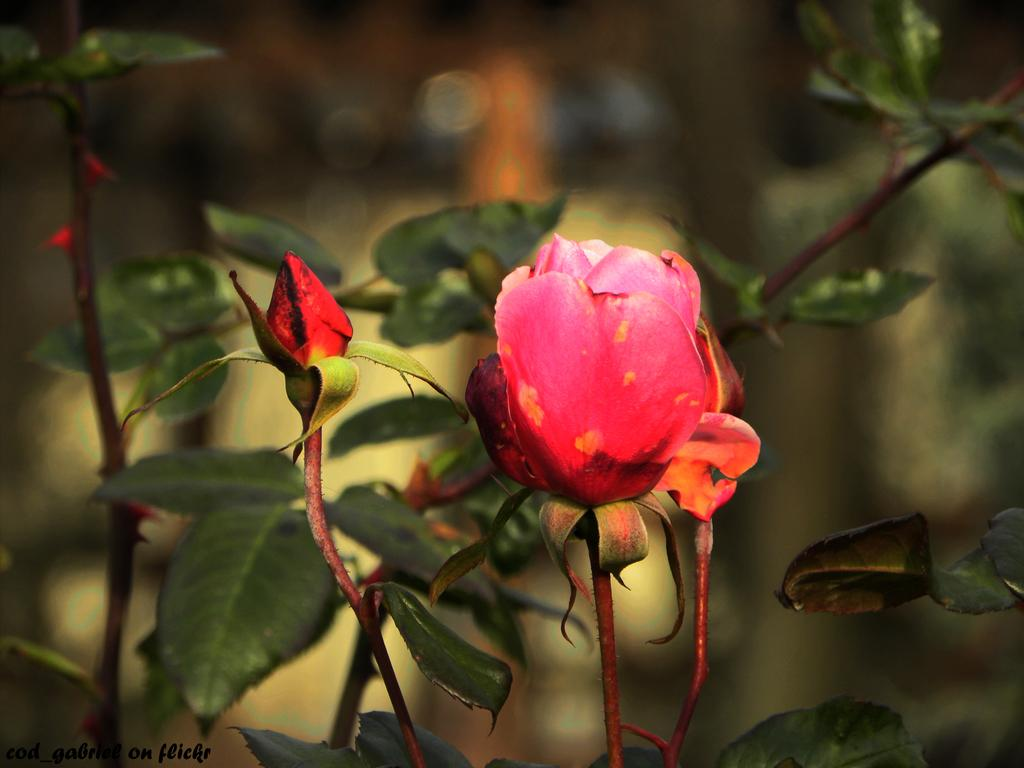What is the main subject of the image? There is a flower in the image. Can you describe the colors of the flower? The flower has pink, orange, and red colors. Where is the flower located? The flower is on a tree. What other elements can be seen in the image? There are green leaves in the image. How would you describe the background of the image? The background of the image is blurry. What type of lace is being used to decorate the servant's stomach in the image? There is no servant or lace present in the image; it features a flower on a tree with green leaves and a blurry background. 